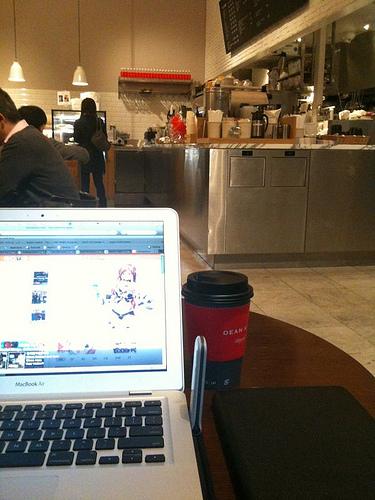Where is the coffee cup?
Be succinct. Next to computer. Is this a nice laptop?
Write a very short answer. Yes. What color is the table?
Be succinct. Brown. 